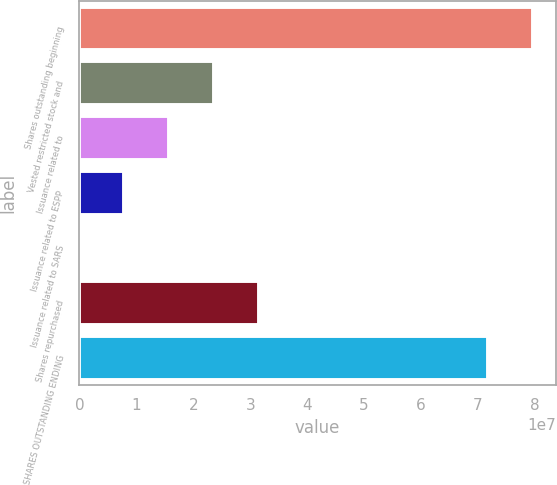Convert chart. <chart><loc_0><loc_0><loc_500><loc_500><bar_chart><fcel>Shares outstanding beginning<fcel>Vested restricted stock and<fcel>Issuance related to<fcel>Issuance related to ESPP<fcel>Issuance related to SARS<fcel>Shares repurchased<fcel>SHARES OUTSTANDING ENDING<nl><fcel>7.96885e+07<fcel>2.3642e+07<fcel>1.57817e+07<fcel>7.92137e+06<fcel>61070<fcel>3.15023e+07<fcel>7.18282e+07<nl></chart> 